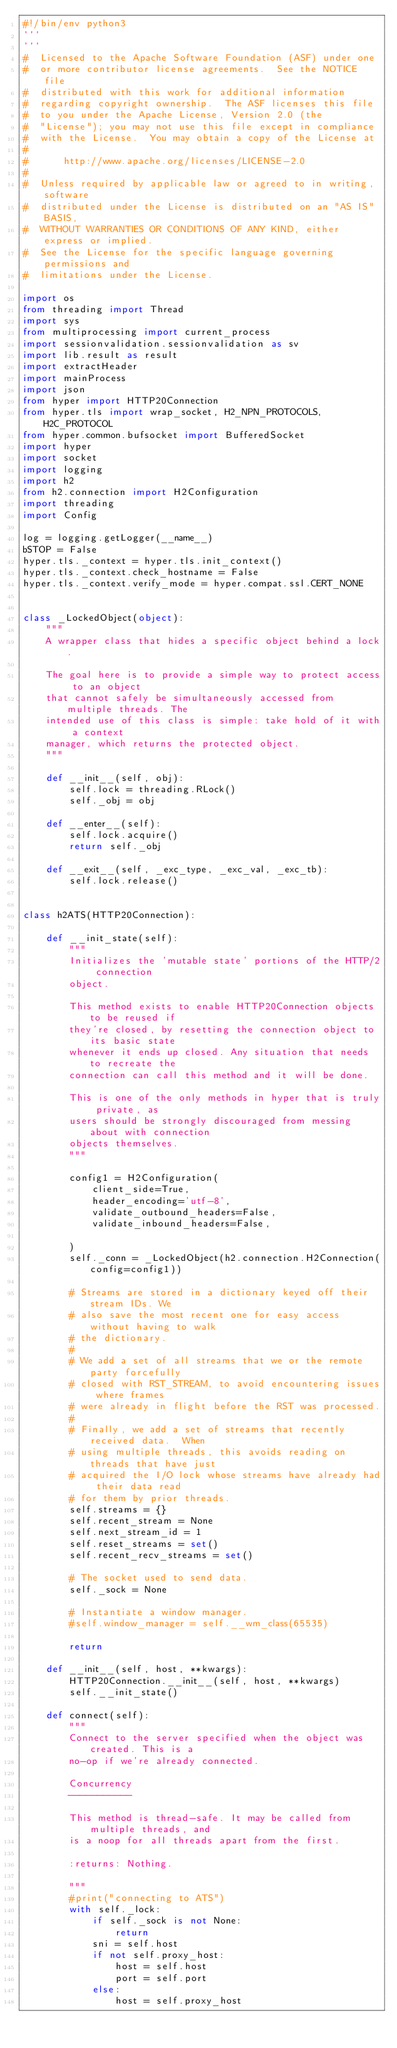Convert code to text. <code><loc_0><loc_0><loc_500><loc_500><_Python_>#!/bin/env python3
'''
'''
#  Licensed to the Apache Software Foundation (ASF) under one
#  or more contributor license agreements.  See the NOTICE file
#  distributed with this work for additional information
#  regarding copyright ownership.  The ASF licenses this file
#  to you under the Apache License, Version 2.0 (the
#  "License"); you may not use this file except in compliance
#  with the License.  You may obtain a copy of the License at
#
#      http://www.apache.org/licenses/LICENSE-2.0
#
#  Unless required by applicable law or agreed to in writing, software
#  distributed under the License is distributed on an "AS IS" BASIS,
#  WITHOUT WARRANTIES OR CONDITIONS OF ANY KIND, either express or implied.
#  See the License for the specific language governing permissions and
#  limitations under the License.

import os
from threading import Thread
import sys
from multiprocessing import current_process
import sessionvalidation.sessionvalidation as sv
import lib.result as result
import extractHeader
import mainProcess
import json
from hyper import HTTP20Connection
from hyper.tls import wrap_socket, H2_NPN_PROTOCOLS, H2C_PROTOCOL
from hyper.common.bufsocket import BufferedSocket
import hyper
import socket
import logging
import h2
from h2.connection import H2Configuration
import threading
import Config

log = logging.getLogger(__name__)
bSTOP = False
hyper.tls._context = hyper.tls.init_context()
hyper.tls._context.check_hostname = False
hyper.tls._context.verify_mode = hyper.compat.ssl.CERT_NONE


class _LockedObject(object):
    """
    A wrapper class that hides a specific object behind a lock.

    The goal here is to provide a simple way to protect access to an object
    that cannot safely be simultaneously accessed from multiple threads. The
    intended use of this class is simple: take hold of it with a context
    manager, which returns the protected object.
    """

    def __init__(self, obj):
        self.lock = threading.RLock()
        self._obj = obj

    def __enter__(self):
        self.lock.acquire()
        return self._obj

    def __exit__(self, _exc_type, _exc_val, _exc_tb):
        self.lock.release()


class h2ATS(HTTP20Connection):

    def __init_state(self):
        """
        Initializes the 'mutable state' portions of the HTTP/2 connection
        object.

        This method exists to enable HTTP20Connection objects to be reused if
        they're closed, by resetting the connection object to its basic state
        whenever it ends up closed. Any situation that needs to recreate the
        connection can call this method and it will be done.

        This is one of the only methods in hyper that is truly private, as
        users should be strongly discouraged from messing about with connection
        objects themselves.
        """

        config1 = H2Configuration(
            client_side=True,
            header_encoding='utf-8',
            validate_outbound_headers=False,
            validate_inbound_headers=False,

        )
        self._conn = _LockedObject(h2.connection.H2Connection(config=config1))

        # Streams are stored in a dictionary keyed off their stream IDs. We
        # also save the most recent one for easy access without having to walk
        # the dictionary.
        #
        # We add a set of all streams that we or the remote party forcefully
        # closed with RST_STREAM, to avoid encountering issues where frames
        # were already in flight before the RST was processed.
        #
        # Finally, we add a set of streams that recently received data.  When
        # using multiple threads, this avoids reading on threads that have just
        # acquired the I/O lock whose streams have already had their data read
        # for them by prior threads.
        self.streams = {}
        self.recent_stream = None
        self.next_stream_id = 1
        self.reset_streams = set()
        self.recent_recv_streams = set()

        # The socket used to send data.
        self._sock = None

        # Instantiate a window manager.
        #self.window_manager = self.__wm_class(65535)

        return

    def __init__(self, host, **kwargs):
        HTTP20Connection.__init__(self, host, **kwargs)
        self.__init_state()

    def connect(self):
        """
        Connect to the server specified when the object was created. This is a
        no-op if we're already connected.

        Concurrency
        -----------

        This method is thread-safe. It may be called from multiple threads, and
        is a noop for all threads apart from the first.

        :returns: Nothing.

        """
        #print("connecting to ATS")
        with self._lock:
            if self._sock is not None:
                return
            sni = self.host
            if not self.proxy_host:
                host = self.host
                port = self.port
            else:
                host = self.proxy_host</code> 